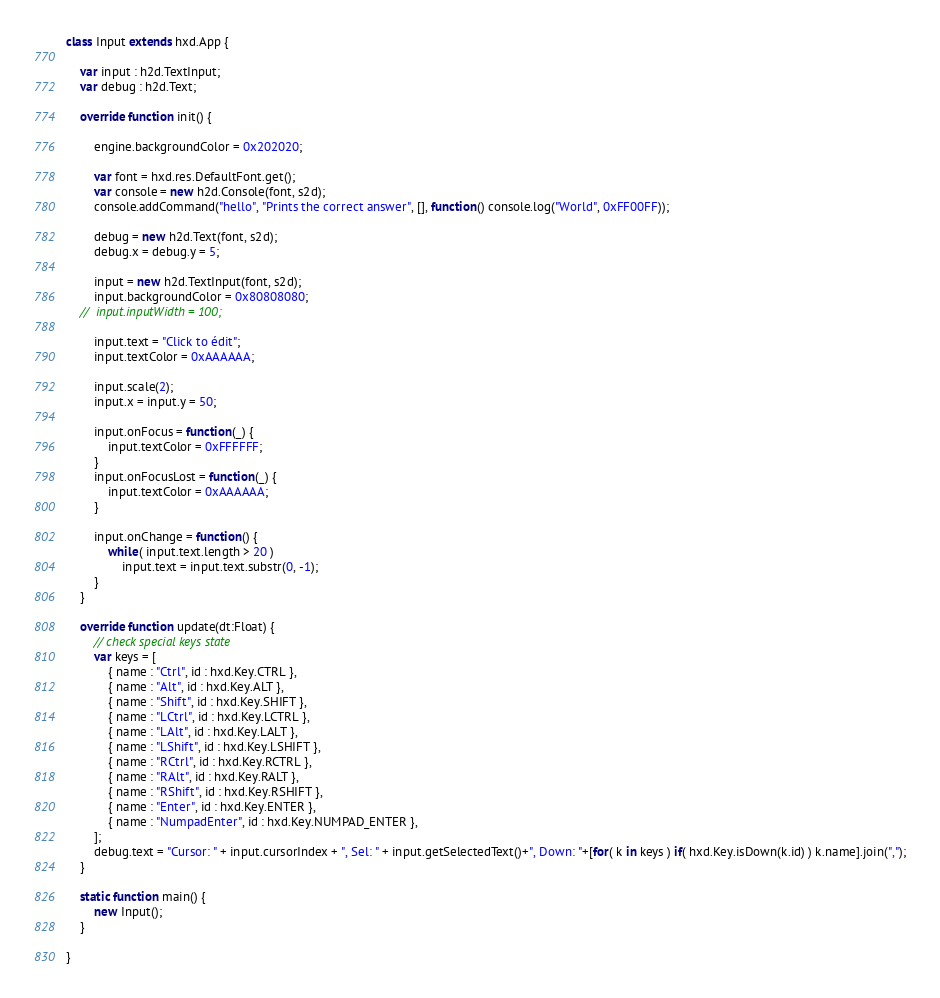Convert code to text. <code><loc_0><loc_0><loc_500><loc_500><_Haxe_>class Input extends hxd.App {

	var input : h2d.TextInput;
	var debug : h2d.Text;

	override function init() {

		engine.backgroundColor = 0x202020;

		var font = hxd.res.DefaultFont.get();
		var console = new h2d.Console(font, s2d);
		console.addCommand("hello", "Prints the correct answer", [], function() console.log("World", 0xFF00FF));

		debug = new h2d.Text(font, s2d);
		debug.x = debug.y = 5;

		input = new h2d.TextInput(font, s2d);
		input.backgroundColor = 0x80808080;
	//	input.inputWidth = 100;

		input.text = "Click to édit";
		input.textColor = 0xAAAAAA;

		input.scale(2);
		input.x = input.y = 50;

		input.onFocus = function(_) {
			input.textColor = 0xFFFFFF;
		}
		input.onFocusLost = function(_) {
			input.textColor = 0xAAAAAA;
		}

		input.onChange = function() {
			while( input.text.length > 20 )
				input.text = input.text.substr(0, -1);
		}
	}

	override function update(dt:Float) {
		// check special keys state
		var keys = [
			{ name : "Ctrl", id : hxd.Key.CTRL },
			{ name : "Alt", id : hxd.Key.ALT },
			{ name : "Shift", id : hxd.Key.SHIFT },
			{ name : "LCtrl", id : hxd.Key.LCTRL },
			{ name : "LAlt", id : hxd.Key.LALT },
			{ name : "LShift", id : hxd.Key.LSHIFT },
			{ name : "RCtrl", id : hxd.Key.RCTRL },
			{ name : "RAlt", id : hxd.Key.RALT },
			{ name : "RShift", id : hxd.Key.RSHIFT },
			{ name : "Enter", id : hxd.Key.ENTER },
			{ name : "NumpadEnter", id : hxd.Key.NUMPAD_ENTER },
		];
		debug.text = "Cursor: " + input.cursorIndex + ", Sel: " + input.getSelectedText()+", Down: "+[for( k in keys ) if( hxd.Key.isDown(k.id) ) k.name].join(",");
	}

	static function main() {
		new Input();
	}

}</code> 